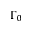Convert formula to latex. <formula><loc_0><loc_0><loc_500><loc_500>\Gamma _ { 0 }</formula> 